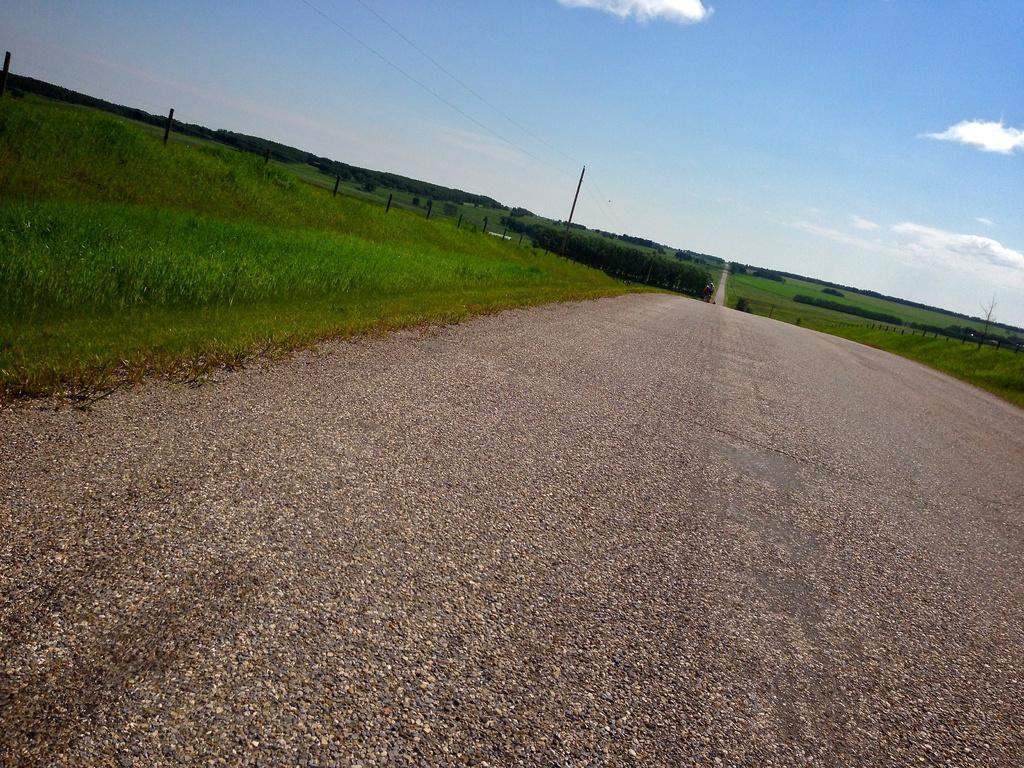What type of surface can be seen in the image? There is a pathway in the image. What type of vegetation is present in the image? There is grass and plants in the image. What structures can be seen in the image? There are poles in the image. What natural feature is visible in the image? There is a group of trees in the image. What else can be seen in the image? There are wires in the image. What is visible in the sky in the image? The sky is visible in the image, and it appears to be cloudy. How does the grandmother comfort the plants in the image? There is no grandmother present in the image, and therefore, no comforting of the plants can be observed. 